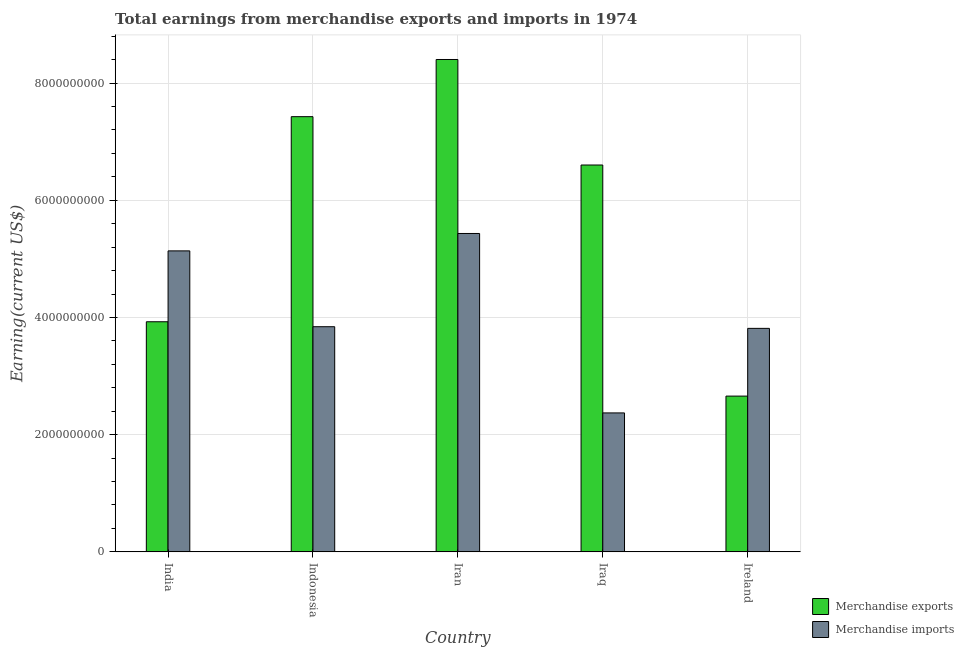Are the number of bars per tick equal to the number of legend labels?
Provide a succinct answer. Yes. What is the label of the 3rd group of bars from the left?
Offer a very short reply. Iran. What is the earnings from merchandise exports in Iraq?
Keep it short and to the point. 6.60e+09. Across all countries, what is the maximum earnings from merchandise imports?
Keep it short and to the point. 5.43e+09. Across all countries, what is the minimum earnings from merchandise exports?
Offer a very short reply. 2.66e+09. In which country was the earnings from merchandise exports maximum?
Offer a terse response. Iran. In which country was the earnings from merchandise exports minimum?
Offer a terse response. Ireland. What is the total earnings from merchandise imports in the graph?
Offer a very short reply. 2.06e+1. What is the difference between the earnings from merchandise imports in Indonesia and that in Ireland?
Your answer should be compact. 2.83e+07. What is the difference between the earnings from merchandise imports in India and the earnings from merchandise exports in Iraq?
Keep it short and to the point. -1.47e+09. What is the average earnings from merchandise imports per country?
Ensure brevity in your answer.  4.12e+09. What is the difference between the earnings from merchandise exports and earnings from merchandise imports in India?
Offer a terse response. -1.21e+09. What is the ratio of the earnings from merchandise imports in Iran to that in Ireland?
Make the answer very short. 1.42. What is the difference between the highest and the second highest earnings from merchandise exports?
Your response must be concise. 9.76e+08. What is the difference between the highest and the lowest earnings from merchandise exports?
Offer a very short reply. 5.74e+09. In how many countries, is the earnings from merchandise imports greater than the average earnings from merchandise imports taken over all countries?
Offer a terse response. 2. What does the 1st bar from the left in Iraq represents?
Your answer should be very brief. Merchandise exports. What does the 1st bar from the right in Indonesia represents?
Your answer should be compact. Merchandise imports. Are all the bars in the graph horizontal?
Offer a terse response. No. How many countries are there in the graph?
Your response must be concise. 5. What is the difference between two consecutive major ticks on the Y-axis?
Offer a terse response. 2.00e+09. Does the graph contain any zero values?
Offer a very short reply. No. Where does the legend appear in the graph?
Your answer should be very brief. Bottom right. How many legend labels are there?
Offer a terse response. 2. How are the legend labels stacked?
Ensure brevity in your answer.  Vertical. What is the title of the graph?
Ensure brevity in your answer.  Total earnings from merchandise exports and imports in 1974. What is the label or title of the X-axis?
Your response must be concise. Country. What is the label or title of the Y-axis?
Provide a succinct answer. Earning(current US$). What is the Earning(current US$) of Merchandise exports in India?
Give a very brief answer. 3.93e+09. What is the Earning(current US$) of Merchandise imports in India?
Provide a short and direct response. 5.14e+09. What is the Earning(current US$) in Merchandise exports in Indonesia?
Your answer should be compact. 7.43e+09. What is the Earning(current US$) of Merchandise imports in Indonesia?
Keep it short and to the point. 3.84e+09. What is the Earning(current US$) in Merchandise exports in Iran?
Offer a terse response. 8.40e+09. What is the Earning(current US$) of Merchandise imports in Iran?
Offer a terse response. 5.43e+09. What is the Earning(current US$) of Merchandise exports in Iraq?
Offer a terse response. 6.60e+09. What is the Earning(current US$) of Merchandise imports in Iraq?
Your answer should be very brief. 2.37e+09. What is the Earning(current US$) of Merchandise exports in Ireland?
Provide a succinct answer. 2.66e+09. What is the Earning(current US$) of Merchandise imports in Ireland?
Make the answer very short. 3.81e+09. Across all countries, what is the maximum Earning(current US$) of Merchandise exports?
Make the answer very short. 8.40e+09. Across all countries, what is the maximum Earning(current US$) of Merchandise imports?
Ensure brevity in your answer.  5.43e+09. Across all countries, what is the minimum Earning(current US$) of Merchandise exports?
Your answer should be very brief. 2.66e+09. Across all countries, what is the minimum Earning(current US$) of Merchandise imports?
Offer a very short reply. 2.37e+09. What is the total Earning(current US$) in Merchandise exports in the graph?
Give a very brief answer. 2.90e+1. What is the total Earning(current US$) in Merchandise imports in the graph?
Your answer should be very brief. 2.06e+1. What is the difference between the Earning(current US$) of Merchandise exports in India and that in Indonesia?
Give a very brief answer. -3.50e+09. What is the difference between the Earning(current US$) in Merchandise imports in India and that in Indonesia?
Offer a very short reply. 1.29e+09. What is the difference between the Earning(current US$) of Merchandise exports in India and that in Iran?
Give a very brief answer. -4.48e+09. What is the difference between the Earning(current US$) of Merchandise imports in India and that in Iran?
Make the answer very short. -2.97e+08. What is the difference between the Earning(current US$) of Merchandise exports in India and that in Iraq?
Offer a very short reply. -2.67e+09. What is the difference between the Earning(current US$) of Merchandise imports in India and that in Iraq?
Your answer should be very brief. 2.76e+09. What is the difference between the Earning(current US$) of Merchandise exports in India and that in Ireland?
Provide a succinct answer. 1.27e+09. What is the difference between the Earning(current US$) in Merchandise imports in India and that in Ireland?
Give a very brief answer. 1.32e+09. What is the difference between the Earning(current US$) in Merchandise exports in Indonesia and that in Iran?
Your answer should be very brief. -9.76e+08. What is the difference between the Earning(current US$) of Merchandise imports in Indonesia and that in Iran?
Your response must be concise. -1.59e+09. What is the difference between the Earning(current US$) in Merchandise exports in Indonesia and that in Iraq?
Ensure brevity in your answer.  8.25e+08. What is the difference between the Earning(current US$) in Merchandise imports in Indonesia and that in Iraq?
Ensure brevity in your answer.  1.47e+09. What is the difference between the Earning(current US$) of Merchandise exports in Indonesia and that in Ireland?
Your answer should be very brief. 4.77e+09. What is the difference between the Earning(current US$) of Merchandise imports in Indonesia and that in Ireland?
Ensure brevity in your answer.  2.83e+07. What is the difference between the Earning(current US$) in Merchandise exports in Iran and that in Iraq?
Give a very brief answer. 1.80e+09. What is the difference between the Earning(current US$) of Merchandise imports in Iran and that in Iraq?
Give a very brief answer. 3.06e+09. What is the difference between the Earning(current US$) of Merchandise exports in Iran and that in Ireland?
Offer a very short reply. 5.74e+09. What is the difference between the Earning(current US$) of Merchandise imports in Iran and that in Ireland?
Provide a short and direct response. 1.62e+09. What is the difference between the Earning(current US$) in Merchandise exports in Iraq and that in Ireland?
Provide a short and direct response. 3.94e+09. What is the difference between the Earning(current US$) of Merchandise imports in Iraq and that in Ireland?
Ensure brevity in your answer.  -1.44e+09. What is the difference between the Earning(current US$) of Merchandise exports in India and the Earning(current US$) of Merchandise imports in Indonesia?
Keep it short and to the point. 8.45e+07. What is the difference between the Earning(current US$) in Merchandise exports in India and the Earning(current US$) in Merchandise imports in Iran?
Offer a very short reply. -1.51e+09. What is the difference between the Earning(current US$) in Merchandise exports in India and the Earning(current US$) in Merchandise imports in Iraq?
Provide a short and direct response. 1.56e+09. What is the difference between the Earning(current US$) in Merchandise exports in India and the Earning(current US$) in Merchandise imports in Ireland?
Offer a terse response. 1.13e+08. What is the difference between the Earning(current US$) of Merchandise exports in Indonesia and the Earning(current US$) of Merchandise imports in Iran?
Provide a short and direct response. 1.99e+09. What is the difference between the Earning(current US$) in Merchandise exports in Indonesia and the Earning(current US$) in Merchandise imports in Iraq?
Give a very brief answer. 5.06e+09. What is the difference between the Earning(current US$) of Merchandise exports in Indonesia and the Earning(current US$) of Merchandise imports in Ireland?
Your response must be concise. 3.61e+09. What is the difference between the Earning(current US$) of Merchandise exports in Iran and the Earning(current US$) of Merchandise imports in Iraq?
Your response must be concise. 6.03e+09. What is the difference between the Earning(current US$) in Merchandise exports in Iran and the Earning(current US$) in Merchandise imports in Ireland?
Offer a terse response. 4.59e+09. What is the difference between the Earning(current US$) of Merchandise exports in Iraq and the Earning(current US$) of Merchandise imports in Ireland?
Ensure brevity in your answer.  2.79e+09. What is the average Earning(current US$) of Merchandise exports per country?
Keep it short and to the point. 5.80e+09. What is the average Earning(current US$) of Merchandise imports per country?
Make the answer very short. 4.12e+09. What is the difference between the Earning(current US$) of Merchandise exports and Earning(current US$) of Merchandise imports in India?
Your answer should be very brief. -1.21e+09. What is the difference between the Earning(current US$) in Merchandise exports and Earning(current US$) in Merchandise imports in Indonesia?
Give a very brief answer. 3.58e+09. What is the difference between the Earning(current US$) of Merchandise exports and Earning(current US$) of Merchandise imports in Iran?
Your answer should be compact. 2.97e+09. What is the difference between the Earning(current US$) in Merchandise exports and Earning(current US$) in Merchandise imports in Iraq?
Your response must be concise. 4.23e+09. What is the difference between the Earning(current US$) in Merchandise exports and Earning(current US$) in Merchandise imports in Ireland?
Your response must be concise. -1.16e+09. What is the ratio of the Earning(current US$) of Merchandise exports in India to that in Indonesia?
Provide a short and direct response. 0.53. What is the ratio of the Earning(current US$) in Merchandise imports in India to that in Indonesia?
Ensure brevity in your answer.  1.34. What is the ratio of the Earning(current US$) in Merchandise exports in India to that in Iran?
Make the answer very short. 0.47. What is the ratio of the Earning(current US$) of Merchandise imports in India to that in Iran?
Your answer should be compact. 0.95. What is the ratio of the Earning(current US$) of Merchandise exports in India to that in Iraq?
Your answer should be very brief. 0.59. What is the ratio of the Earning(current US$) in Merchandise imports in India to that in Iraq?
Provide a short and direct response. 2.17. What is the ratio of the Earning(current US$) of Merchandise exports in India to that in Ireland?
Offer a very short reply. 1.48. What is the ratio of the Earning(current US$) of Merchandise imports in India to that in Ireland?
Provide a short and direct response. 1.35. What is the ratio of the Earning(current US$) of Merchandise exports in Indonesia to that in Iran?
Keep it short and to the point. 0.88. What is the ratio of the Earning(current US$) in Merchandise imports in Indonesia to that in Iran?
Offer a very short reply. 0.71. What is the ratio of the Earning(current US$) of Merchandise imports in Indonesia to that in Iraq?
Offer a terse response. 1.62. What is the ratio of the Earning(current US$) in Merchandise exports in Indonesia to that in Ireland?
Keep it short and to the point. 2.79. What is the ratio of the Earning(current US$) of Merchandise imports in Indonesia to that in Ireland?
Your answer should be very brief. 1.01. What is the ratio of the Earning(current US$) in Merchandise exports in Iran to that in Iraq?
Offer a very short reply. 1.27. What is the ratio of the Earning(current US$) in Merchandise imports in Iran to that in Iraq?
Keep it short and to the point. 2.29. What is the ratio of the Earning(current US$) in Merchandise exports in Iran to that in Ireland?
Keep it short and to the point. 3.16. What is the ratio of the Earning(current US$) in Merchandise imports in Iran to that in Ireland?
Ensure brevity in your answer.  1.42. What is the ratio of the Earning(current US$) in Merchandise exports in Iraq to that in Ireland?
Ensure brevity in your answer.  2.48. What is the ratio of the Earning(current US$) in Merchandise imports in Iraq to that in Ireland?
Provide a succinct answer. 0.62. What is the difference between the highest and the second highest Earning(current US$) of Merchandise exports?
Provide a succinct answer. 9.76e+08. What is the difference between the highest and the second highest Earning(current US$) in Merchandise imports?
Provide a succinct answer. 2.97e+08. What is the difference between the highest and the lowest Earning(current US$) in Merchandise exports?
Provide a succinct answer. 5.74e+09. What is the difference between the highest and the lowest Earning(current US$) of Merchandise imports?
Ensure brevity in your answer.  3.06e+09. 